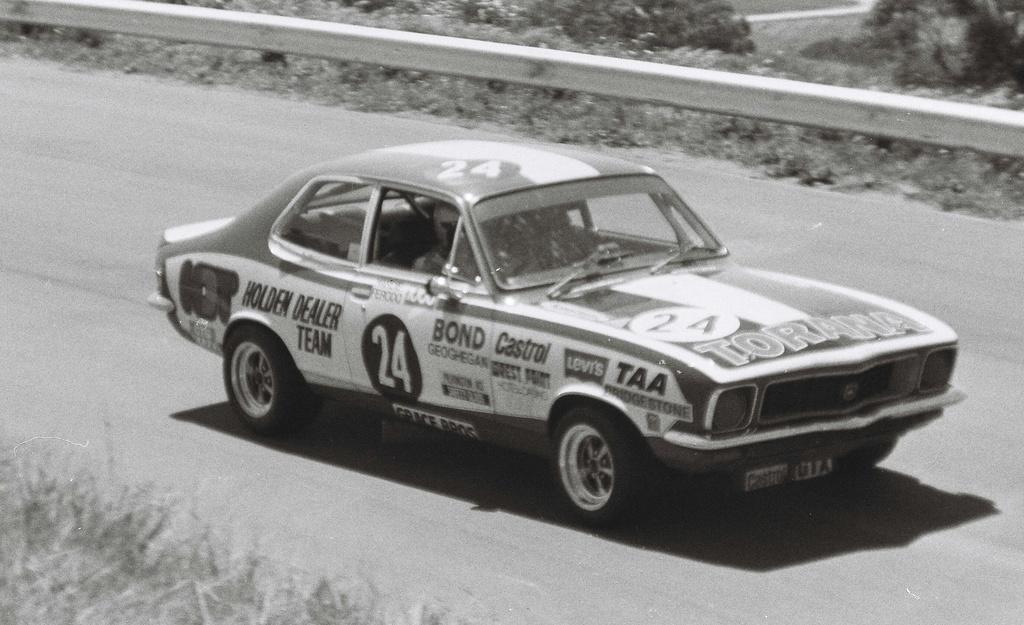How would you summarize this image in a sentence or two? In this image there is road, there is a car on the road, there is a person driving a car, there is text on the car, there is number on the car, there is a road safety barrier, there are plants towards the top of the image, there are plants towards the bottom of the image. 